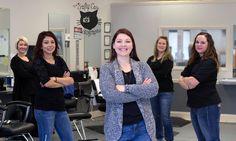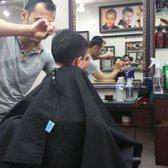The first image is the image on the left, the second image is the image on the right. Examine the images to the left and right. Is the description "In one of the images, people are outside the storefront under the sign." accurate? Answer yes or no. No. The first image is the image on the left, the second image is the image on the right. Examine the images to the left and right. Is the description "One of the images shows a group of exactly women with arms folded." accurate? Answer yes or no. Yes. 